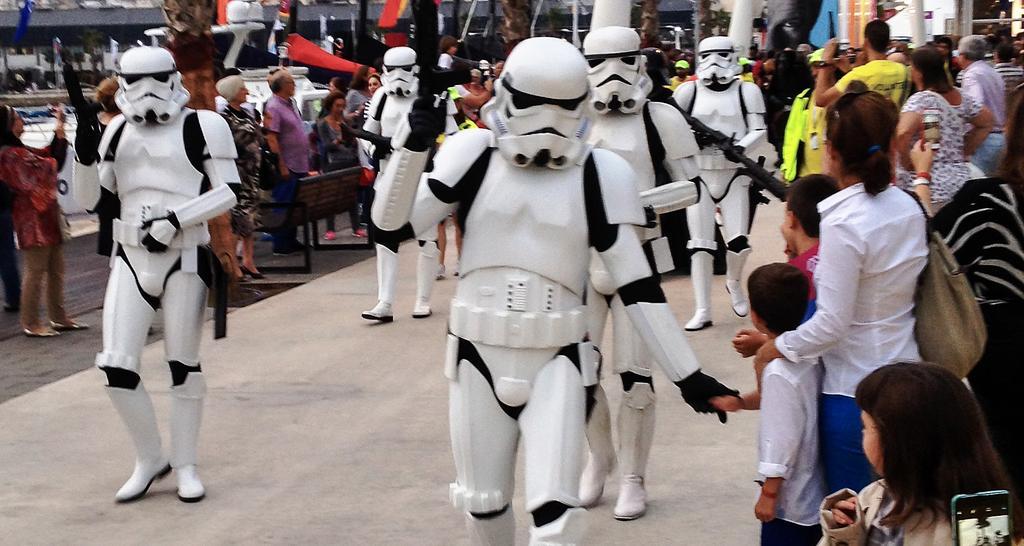Can you describe this image briefly? In this picture we can see some people are standing and some people are walking, the people in the middle are wearing costumes and holding guns, on the left side there is a bench, we can see a building in the background, there is a mobile phone at the right bottom. 